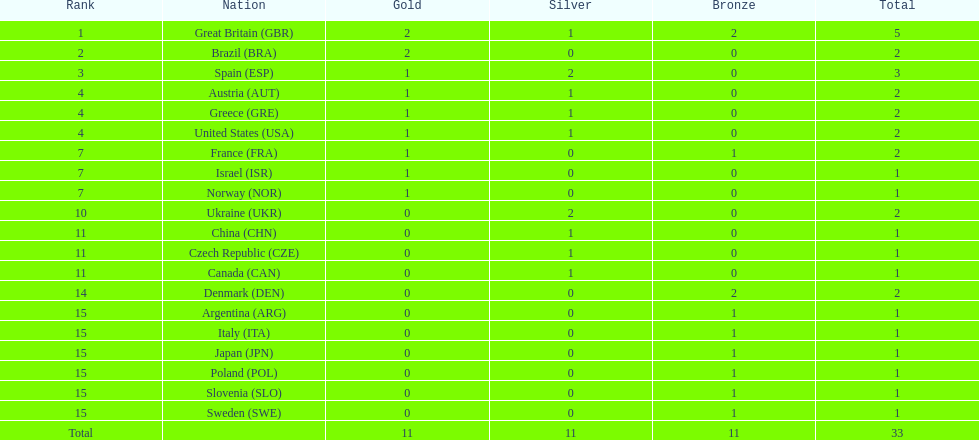Next to great britain, which country had a similar medal count? Spain. 